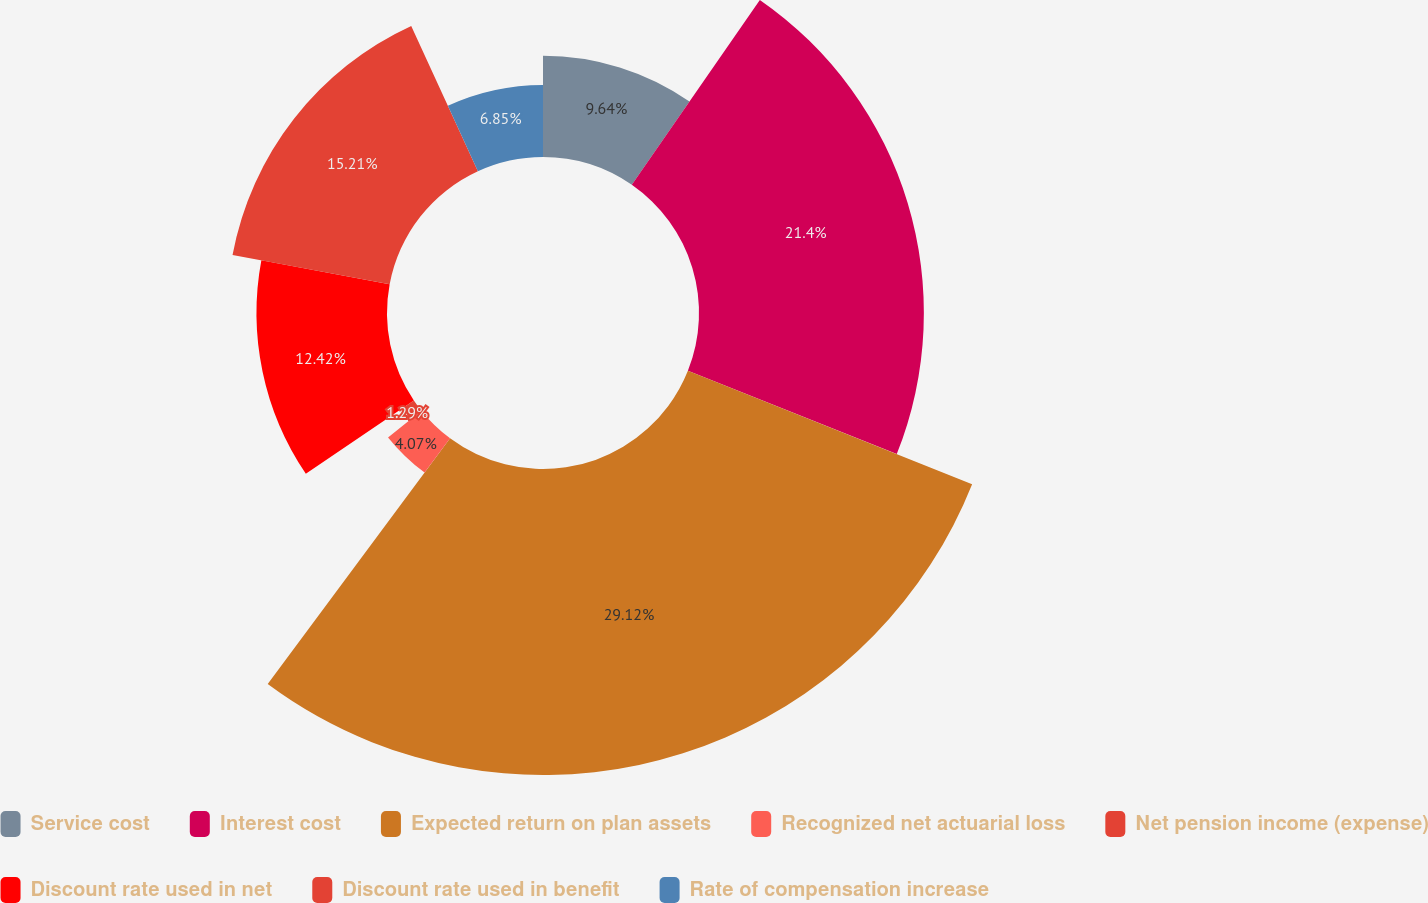Convert chart. <chart><loc_0><loc_0><loc_500><loc_500><pie_chart><fcel>Service cost<fcel>Interest cost<fcel>Expected return on plan assets<fcel>Recognized net actuarial loss<fcel>Net pension income (expense)<fcel>Discount rate used in net<fcel>Discount rate used in benefit<fcel>Rate of compensation increase<nl><fcel>9.64%<fcel>21.4%<fcel>29.12%<fcel>4.07%<fcel>1.29%<fcel>12.42%<fcel>15.21%<fcel>6.85%<nl></chart> 